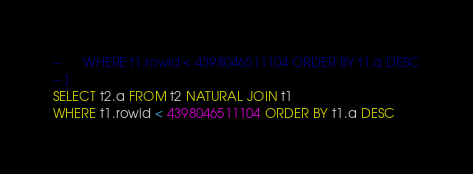<code> <loc_0><loc_0><loc_500><loc_500><_SQL_>--      WHERE t1.rowid < 4398046511104 ORDER BY t1.a DESC
-- }
SELECT t2.a FROM t2 NATURAL JOIN t1
WHERE t1.rowid < 4398046511104 ORDER BY t1.a DESC</code> 